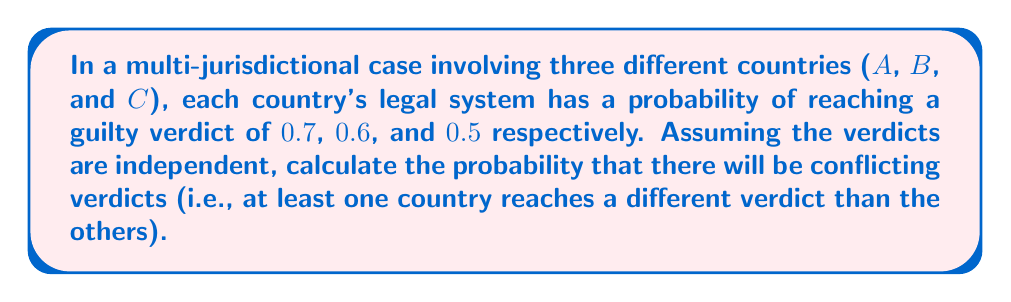Solve this math problem. To solve this problem, we need to use the concept of probability and the complement rule. Let's approach this step-by-step:

1) First, let's calculate the probability that all verdicts agree. This can happen in two ways:
   a) All countries find the defendant guilty
   b) All countries find the defendant not guilty

2) Probability of all countries finding the defendant guilty:
   $P(\text{all guilty}) = 0.7 \times 0.6 \times 0.5 = 0.21$

3) Probability of all countries finding the defendant not guilty:
   $P(\text{all not guilty}) = (1-0.7) \times (1-0.6) \times (1-0.5) = 0.3 \times 0.4 \times 0.5 = 0.06$

4) Probability of all verdicts agreeing:
   $P(\text{all agree}) = P(\text{all guilty}) + P(\text{all not guilty}) = 0.21 + 0.06 = 0.27$

5) The probability of conflicting verdicts is the complement of the probability of all verdicts agreeing:
   $P(\text{conflicting}) = 1 - P(\text{all agree}) = 1 - 0.27 = 0.73$

Therefore, the probability of conflicting verdicts is 0.73 or 73%.
Answer: 0.73 or 73% 